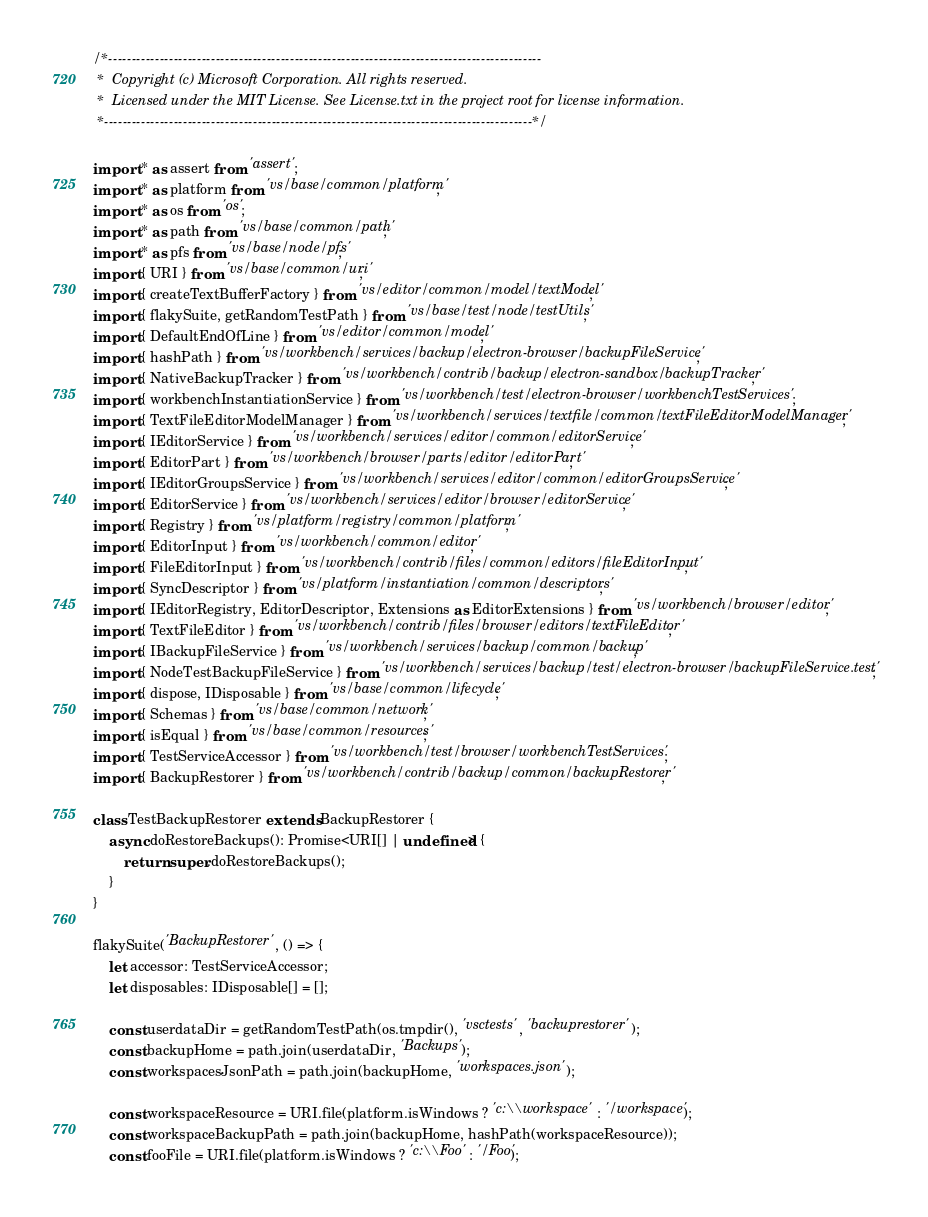Convert code to text. <code><loc_0><loc_0><loc_500><loc_500><_TypeScript_>/*---------------------------------------------------------------------------------------------
 *  Copyright (c) Microsoft Corporation. All rights reserved.
 *  Licensed under the MIT License. See License.txt in the project root for license information.
 *--------------------------------------------------------------------------------------------*/

import * as assert from 'assert';
import * as platform from 'vs/base/common/platform';
import * as os from 'os';
import * as path from 'vs/base/common/path';
import * as pfs from 'vs/base/node/pfs';
import { URI } from 'vs/base/common/uri';
import { createTextBufferFactory } from 'vs/editor/common/model/textModel';
import { flakySuite, getRandomTestPath } from 'vs/base/test/node/testUtils';
import { DefaultEndOfLine } from 'vs/editor/common/model';
import { hashPath } from 'vs/workbench/services/backup/electron-browser/backupFileService';
import { NativeBackupTracker } from 'vs/workbench/contrib/backup/electron-sandbox/backupTracker';
import { workbenchInstantiationService } from 'vs/workbench/test/electron-browser/workbenchTestServices';
import { TextFileEditorModelManager } from 'vs/workbench/services/textfile/common/textFileEditorModelManager';
import { IEditorService } from 'vs/workbench/services/editor/common/editorService';
import { EditorPart } from 'vs/workbench/browser/parts/editor/editorPart';
import { IEditorGroupsService } from 'vs/workbench/services/editor/common/editorGroupsService';
import { EditorService } from 'vs/workbench/services/editor/browser/editorService';
import { Registry } from 'vs/platform/registry/common/platform';
import { EditorInput } from 'vs/workbench/common/editor';
import { FileEditorInput } from 'vs/workbench/contrib/files/common/editors/fileEditorInput';
import { SyncDescriptor } from 'vs/platform/instantiation/common/descriptors';
import { IEditorRegistry, EditorDescriptor, Extensions as EditorExtensions } from 'vs/workbench/browser/editor';
import { TextFileEditor } from 'vs/workbench/contrib/files/browser/editors/textFileEditor';
import { IBackupFileService } from 'vs/workbench/services/backup/common/backup';
import { NodeTestBackupFileService } from 'vs/workbench/services/backup/test/electron-browser/backupFileService.test';
import { dispose, IDisposable } from 'vs/base/common/lifecycle';
import { Schemas } from 'vs/base/common/network';
import { isEqual } from 'vs/base/common/resources';
import { TestServiceAccessor } from 'vs/workbench/test/browser/workbenchTestServices';
import { BackupRestorer } from 'vs/workbench/contrib/backup/common/backupRestorer';

class TestBackupRestorer extends BackupRestorer {
	async doRestoreBackups(): Promise<URI[] | undefined> {
		return super.doRestoreBackups();
	}
}

flakySuite('BackupRestorer', () => {
	let accessor: TestServiceAccessor;
	let disposables: IDisposable[] = [];

	const userdataDir = getRandomTestPath(os.tmpdir(), 'vsctests', 'backuprestorer');
	const backupHome = path.join(userdataDir, 'Backups');
	const workspacesJsonPath = path.join(backupHome, 'workspaces.json');

	const workspaceResource = URI.file(platform.isWindows ? 'c:\\workspace' : '/workspace');
	const workspaceBackupPath = path.join(backupHome, hashPath(workspaceResource));
	const fooFile = URI.file(platform.isWindows ? 'c:\\Foo' : '/Foo');</code> 